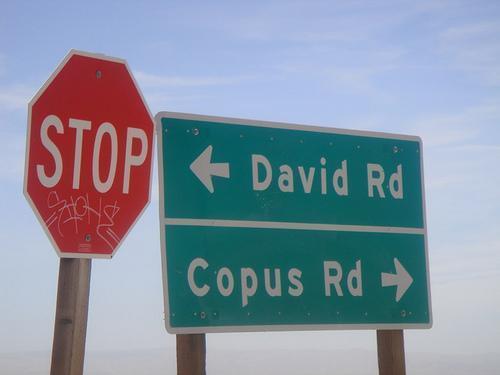How many signs are there?
Give a very brief answer. 2. 